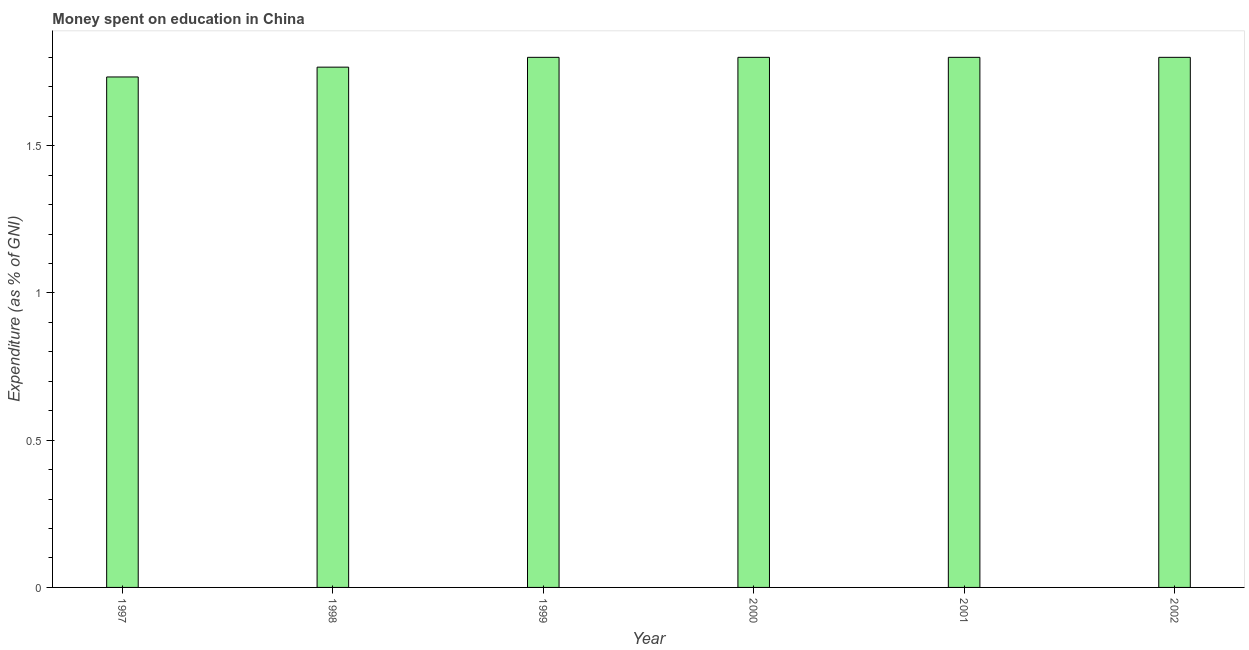Does the graph contain grids?
Provide a succinct answer. No. What is the title of the graph?
Make the answer very short. Money spent on education in China. What is the label or title of the Y-axis?
Make the answer very short. Expenditure (as % of GNI). What is the expenditure on education in 1999?
Ensure brevity in your answer.  1.8. Across all years, what is the minimum expenditure on education?
Give a very brief answer. 1.73. In which year was the expenditure on education maximum?
Offer a very short reply. 1999. What is the sum of the expenditure on education?
Provide a short and direct response. 10.7. What is the average expenditure on education per year?
Your answer should be very brief. 1.78. What is the median expenditure on education?
Ensure brevity in your answer.  1.8. In how many years, is the expenditure on education greater than 0.9 %?
Make the answer very short. 6. Do a majority of the years between 1999 and 1997 (inclusive) have expenditure on education greater than 1 %?
Your answer should be compact. Yes. Is the difference between the expenditure on education in 1997 and 2001 greater than the difference between any two years?
Ensure brevity in your answer.  Yes. Is the sum of the expenditure on education in 1997 and 2000 greater than the maximum expenditure on education across all years?
Make the answer very short. Yes. What is the difference between the highest and the lowest expenditure on education?
Keep it short and to the point. 0.07. How many bars are there?
Give a very brief answer. 6. Are all the bars in the graph horizontal?
Provide a short and direct response. No. How many years are there in the graph?
Provide a short and direct response. 6. Are the values on the major ticks of Y-axis written in scientific E-notation?
Make the answer very short. No. What is the Expenditure (as % of GNI) of 1997?
Keep it short and to the point. 1.73. What is the Expenditure (as % of GNI) of 1998?
Make the answer very short. 1.77. What is the Expenditure (as % of GNI) of 1999?
Offer a terse response. 1.8. What is the difference between the Expenditure (as % of GNI) in 1997 and 1998?
Keep it short and to the point. -0.03. What is the difference between the Expenditure (as % of GNI) in 1997 and 1999?
Your answer should be compact. -0.07. What is the difference between the Expenditure (as % of GNI) in 1997 and 2000?
Make the answer very short. -0.07. What is the difference between the Expenditure (as % of GNI) in 1997 and 2001?
Your response must be concise. -0.07. What is the difference between the Expenditure (as % of GNI) in 1997 and 2002?
Provide a short and direct response. -0.07. What is the difference between the Expenditure (as % of GNI) in 1998 and 1999?
Offer a very short reply. -0.03. What is the difference between the Expenditure (as % of GNI) in 1998 and 2000?
Provide a succinct answer. -0.03. What is the difference between the Expenditure (as % of GNI) in 1998 and 2001?
Provide a short and direct response. -0.03. What is the difference between the Expenditure (as % of GNI) in 1998 and 2002?
Offer a terse response. -0.03. What is the difference between the Expenditure (as % of GNI) in 2000 and 2001?
Provide a short and direct response. 0. What is the difference between the Expenditure (as % of GNI) in 2001 and 2002?
Provide a succinct answer. 0. What is the ratio of the Expenditure (as % of GNI) in 1997 to that in 2000?
Make the answer very short. 0.96. What is the ratio of the Expenditure (as % of GNI) in 1997 to that in 2001?
Your answer should be compact. 0.96. What is the ratio of the Expenditure (as % of GNI) in 1997 to that in 2002?
Your response must be concise. 0.96. What is the ratio of the Expenditure (as % of GNI) in 1998 to that in 1999?
Offer a very short reply. 0.98. What is the ratio of the Expenditure (as % of GNI) in 1998 to that in 2001?
Your answer should be very brief. 0.98. What is the ratio of the Expenditure (as % of GNI) in 1999 to that in 2000?
Keep it short and to the point. 1. What is the ratio of the Expenditure (as % of GNI) in 1999 to that in 2002?
Your answer should be compact. 1. What is the ratio of the Expenditure (as % of GNI) in 2000 to that in 2001?
Your response must be concise. 1. 